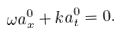Convert formula to latex. <formula><loc_0><loc_0><loc_500><loc_500>\omega a ^ { 0 } _ { x } + k a ^ { 0 } _ { t } = 0 .</formula> 